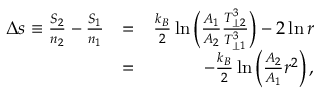Convert formula to latex. <formula><loc_0><loc_0><loc_500><loc_500>\begin{array} { r l r } { \Delta s \equiv \frac { S _ { 2 } } { n _ { 2 } } - \frac { S _ { 1 } } { n _ { 1 } } } & { = } & { \frac { k _ { B } } { 2 } \ln \left ( \frac { A _ { 1 } } { A _ { 2 } } \frac { T _ { \perp 2 } ^ { 3 } } { T _ { \perp 1 } ^ { 3 } } \right ) - 2 \ln r } \\ & { = } & { - \frac { k _ { B } } { 2 } \ln \left ( \frac { A _ { 2 } } { A _ { 1 } } r ^ { 2 } \right ) , } \end{array}</formula> 